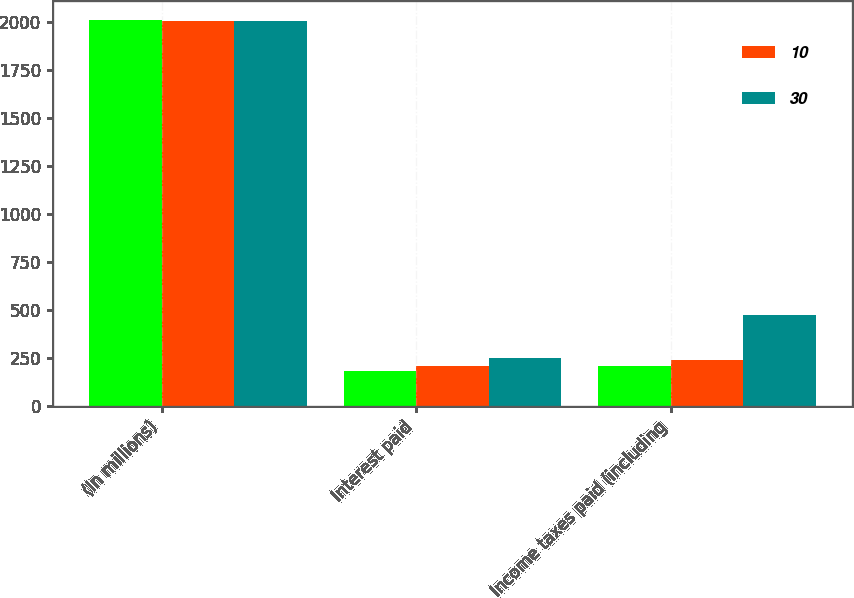Convert chart. <chart><loc_0><loc_0><loc_500><loc_500><stacked_bar_chart><ecel><fcel>(In millions)<fcel>Interest paid<fcel>Income taxes paid (including<nl><fcel>nan<fcel>2010<fcel>182<fcel>209<nl><fcel>10<fcel>2009<fcel>211<fcel>242<nl><fcel>30<fcel>2008<fcel>252<fcel>474<nl></chart> 